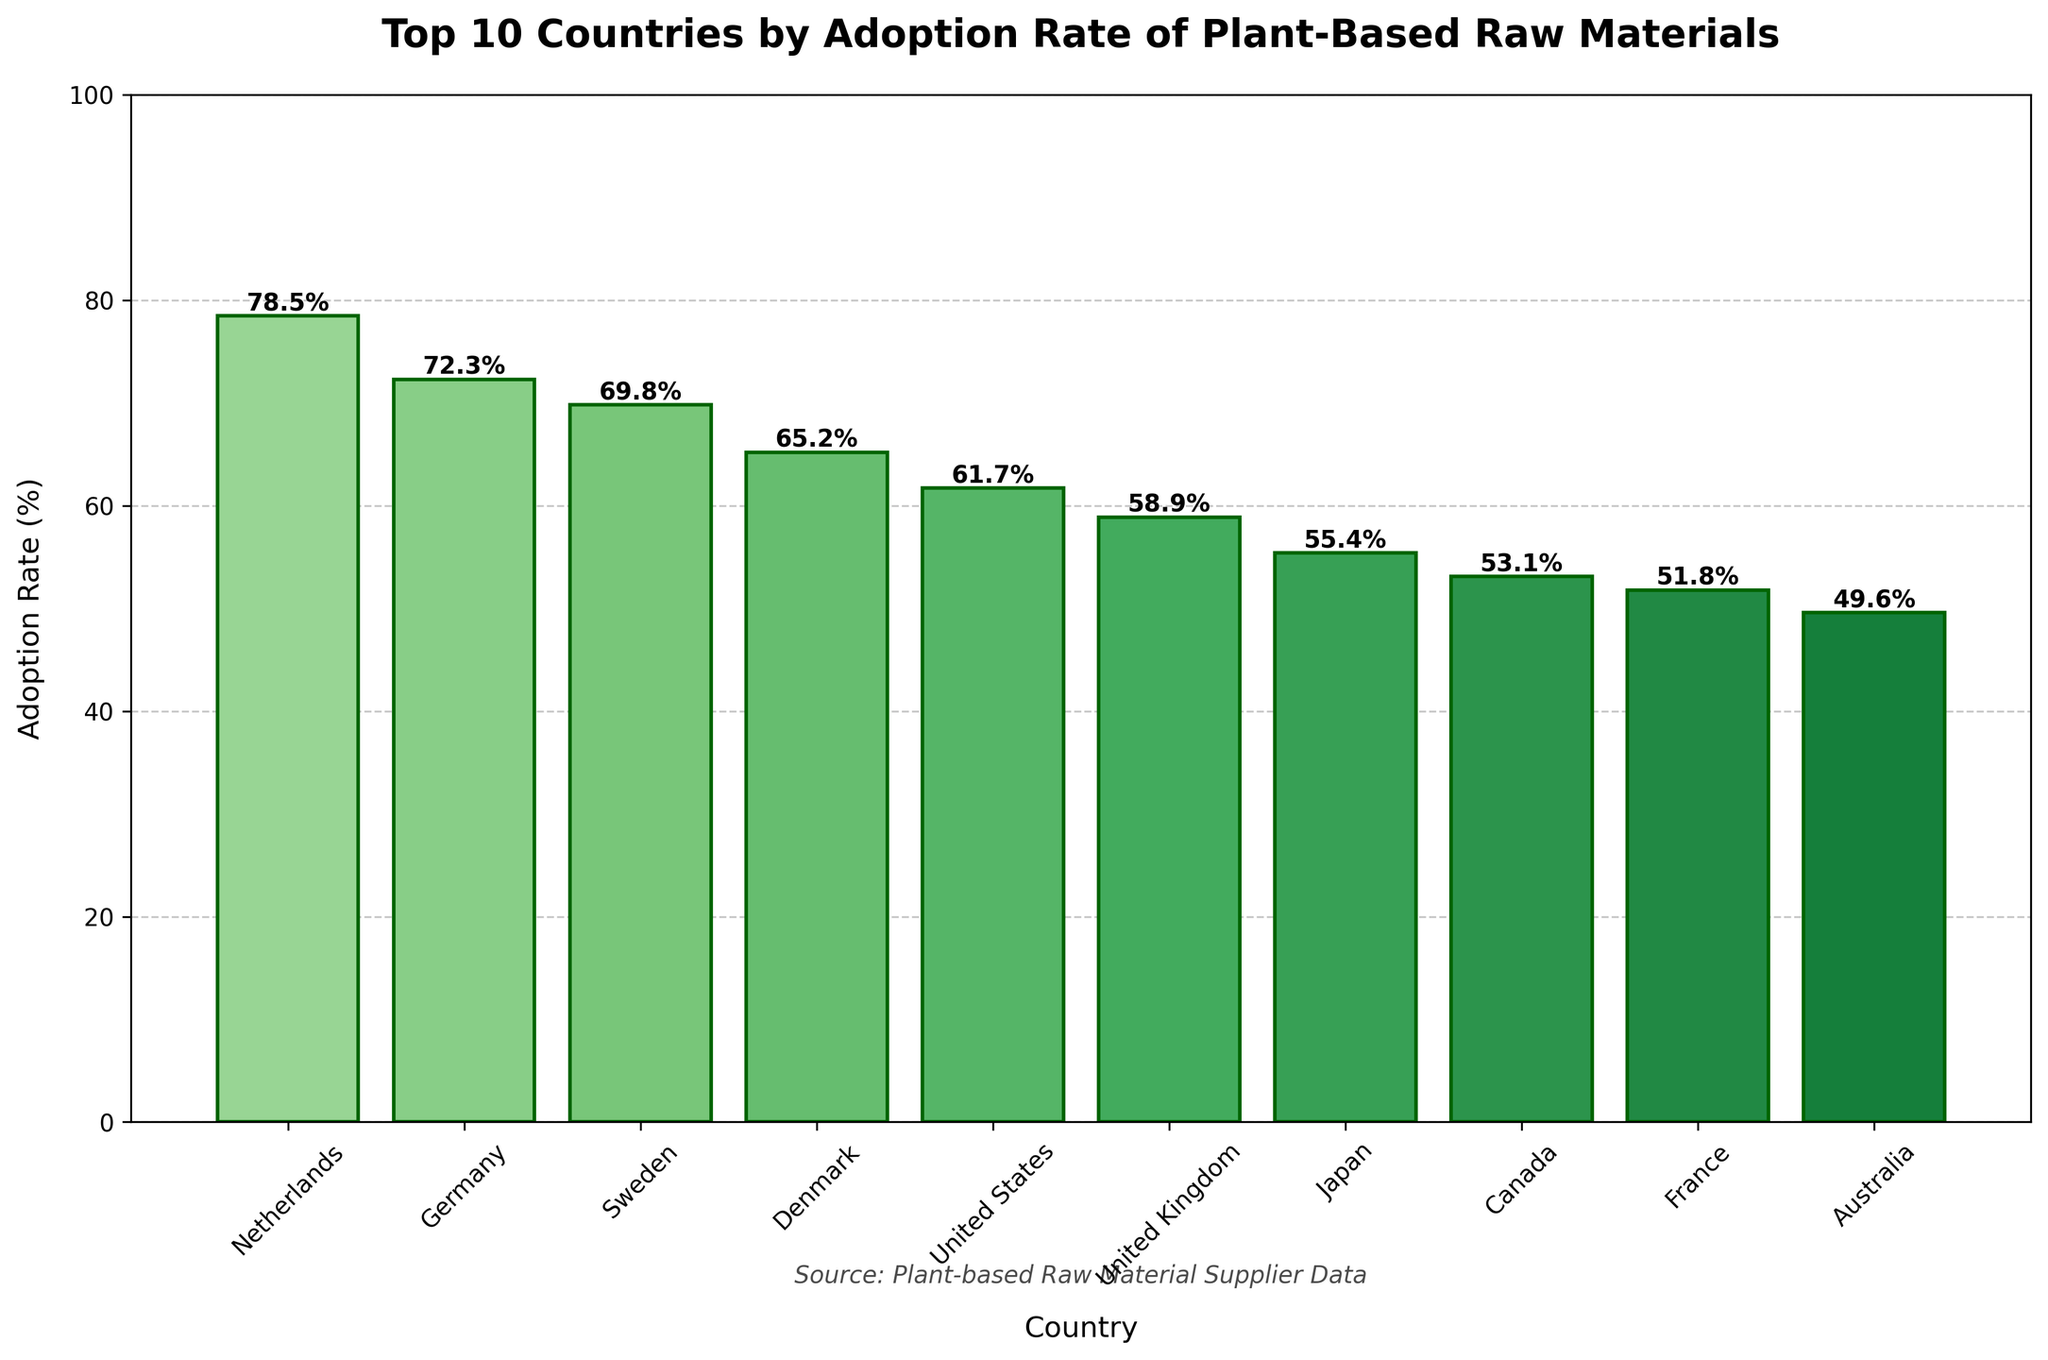What's the country with the highest adoption rate? The country with the highest bar on the chart represents the highest adoption rate. This is the Netherlands with a 78.5% adoption rate.
Answer: Netherlands Which country has the lowest adoption rate among the top 10? The country with the shortest bar on the chart has the lowest adoption rate, which is Australia with a 49.6% adoption rate.
Answer: Australia What is the difference in adoption rate between the Netherlands and Australia? The adoption rate of the Netherlands is 78.5% and Australia is 49.6%. Subtracting these values gives 78.5% - 49.6% = 28.9%.
Answer: 28.9% Which countries have an adoption rate greater than 60%? The countries with bars extending above the 60% mark are: Netherlands (78.5%), Germany (72.3%), Sweden (69.8%), Denmark (65.2%), and United States (61.7%).
Answer: Netherlands, Germany, Sweden, Denmark, United States How many countries have an adoption rate between 50% and 60%? The bars representing countries with adoption rates between 50% and 60% are those of the United Kingdom (58.9%), Japan (55.4%), Canada (53.1%), and France (51.8%). Thus, there are four countries.
Answer: 4 What's the average adoption rate of the Top 10 countries? Adding all adoption rates: 78.5 + 72.3 + 69.8 + 65.2 + 61.7 + 58.9 + 55.4 + 53.1 + 51.8 + 49.6 = 616.3. Dividing by the number of countries (10) gives 616.3 / 10 = 61.63%.
Answer: 61.63% Compare the adoption rates of Sweden and Japan. Sweden has an adoption rate of 69.8%, while Japan's rate is 55.4%. Sweden has a higher adoption rate than Japan.
Answer: Sweden > Japan Which country among the Top 10 is closest in adoption rate to the United States? The United States has an adoption rate of 61.7%. The country closest to this rate is Denmark at 65.2%.
Answer: Denmark Are there more countries with adoption rates above or below 55%? Countries with adoption rates above 55%: Netherlands, Germany, Sweden, Denmark, United States, and United Kingdom (6 countries). Countries with rates below 55%: Japan, Canada, France, and Australia (4 countries). Thus, there are more countries above 55%.
Answer: Above What is the combined adoption rate of Germany, Denmark, and France? Summing the adoption rates of Germany (72.3%), Denmark (65.2%), and France (51.8%) gives 72.3 + 65.2 + 51.8 = 189.3%.
Answer: 189.3% 